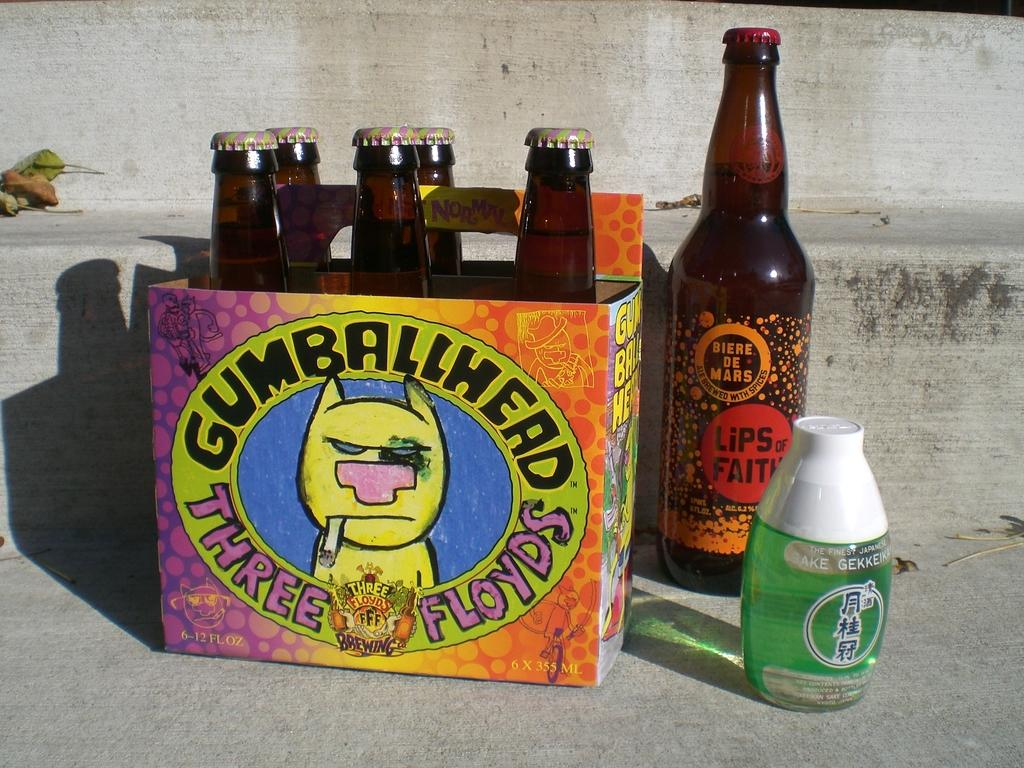<image>
Present a compact description of the photo's key features. Six pack of Gumballhead Three Floyds guy with cigarette hanging out of his mouth. 